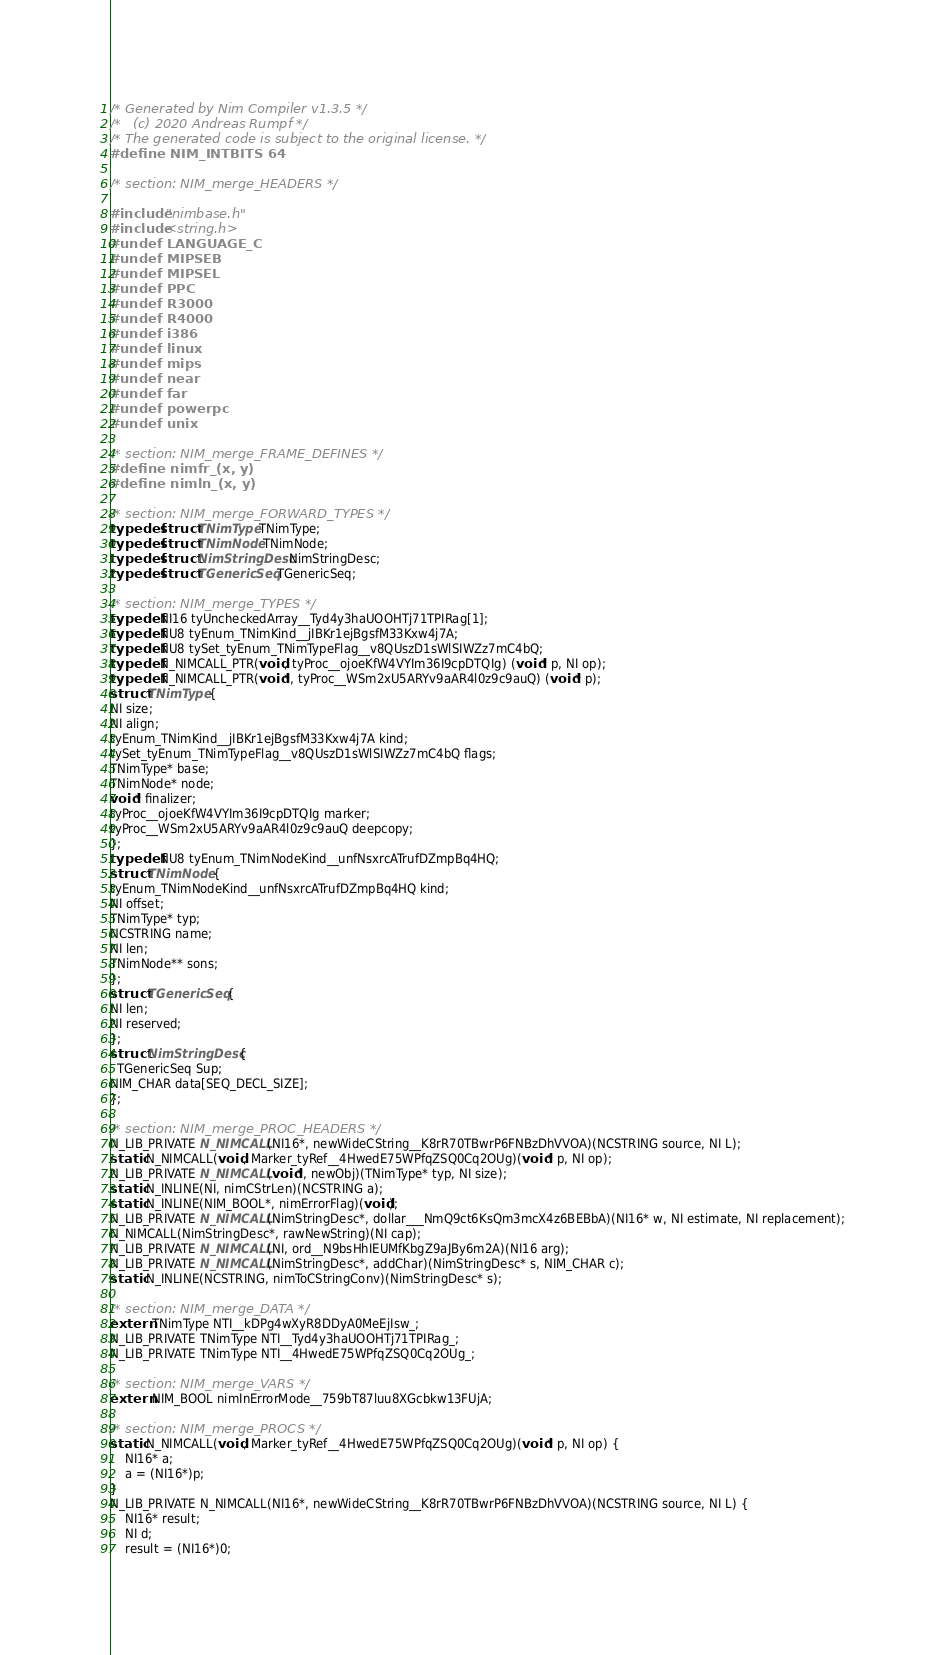<code> <loc_0><loc_0><loc_500><loc_500><_C_>/* Generated by Nim Compiler v1.3.5 */
/*   (c) 2020 Andreas Rumpf */
/* The generated code is subject to the original license. */
#define NIM_INTBITS 64

/* section: NIM_merge_HEADERS */

#include "nimbase.h"
#include <string.h>
#undef LANGUAGE_C
#undef MIPSEB
#undef MIPSEL
#undef PPC
#undef R3000
#undef R4000
#undef i386
#undef linux
#undef mips
#undef near
#undef far
#undef powerpc
#undef unix

/* section: NIM_merge_FRAME_DEFINES */
#define nimfr_(x, y)
#define nimln_(x, y)

/* section: NIM_merge_FORWARD_TYPES */
typedef struct TNimType TNimType;
typedef struct TNimNode TNimNode;
typedef struct NimStringDesc NimStringDesc;
typedef struct TGenericSeq TGenericSeq;

/* section: NIM_merge_TYPES */
typedef NI16 tyUncheckedArray__Tyd4y3haUOOHTj71TPIRag[1];
typedef NU8 tyEnum_TNimKind__jIBKr1ejBgsfM33Kxw4j7A;
typedef NU8 tySet_tyEnum_TNimTypeFlag__v8QUszD1sWlSIWZz7mC4bQ;
typedef N_NIMCALL_PTR(void, tyProc__ojoeKfW4VYIm36I9cpDTQIg) (void* p, NI op);
typedef N_NIMCALL_PTR(void*, tyProc__WSm2xU5ARYv9aAR4l0z9c9auQ) (void* p);
struct TNimType {
NI size;
NI align;
tyEnum_TNimKind__jIBKr1ejBgsfM33Kxw4j7A kind;
tySet_tyEnum_TNimTypeFlag__v8QUszD1sWlSIWZz7mC4bQ flags;
TNimType* base;
TNimNode* node;
void* finalizer;
tyProc__ojoeKfW4VYIm36I9cpDTQIg marker;
tyProc__WSm2xU5ARYv9aAR4l0z9c9auQ deepcopy;
};
typedef NU8 tyEnum_TNimNodeKind__unfNsxrcATrufDZmpBq4HQ;
struct TNimNode {
tyEnum_TNimNodeKind__unfNsxrcATrufDZmpBq4HQ kind;
NI offset;
TNimType* typ;
NCSTRING name;
NI len;
TNimNode** sons;
};
struct TGenericSeq {
NI len;
NI reserved;
};
struct NimStringDesc {
  TGenericSeq Sup;
NIM_CHAR data[SEQ_DECL_SIZE];
};

/* section: NIM_merge_PROC_HEADERS */
N_LIB_PRIVATE N_NIMCALL(NI16*, newWideCString__K8rR70TBwrP6FNBzDhVVOA)(NCSTRING source, NI L);
static N_NIMCALL(void, Marker_tyRef__4HwedE75WPfqZSQ0Cq2OUg)(void* p, NI op);
N_LIB_PRIVATE N_NIMCALL(void*, newObj)(TNimType* typ, NI size);
static N_INLINE(NI, nimCStrLen)(NCSTRING a);
static N_INLINE(NIM_BOOL*, nimErrorFlag)(void);
N_LIB_PRIVATE N_NIMCALL(NimStringDesc*, dollar___NmQ9ct6KsQm3mcX4z6BEBbA)(NI16* w, NI estimate, NI replacement);
N_NIMCALL(NimStringDesc*, rawNewString)(NI cap);
N_LIB_PRIVATE N_NIMCALL(NI, ord__N9bsHhIEUMfKbgZ9aJBy6m2A)(NI16 arg);
N_LIB_PRIVATE N_NIMCALL(NimStringDesc*, addChar)(NimStringDesc* s, NIM_CHAR c);
static N_INLINE(NCSTRING, nimToCStringConv)(NimStringDesc* s);

/* section: NIM_merge_DATA */
extern TNimType NTI__kDPg4wXyR8DDyA0MeEjIsw_;
N_LIB_PRIVATE TNimType NTI__Tyd4y3haUOOHTj71TPIRag_;
N_LIB_PRIVATE TNimType NTI__4HwedE75WPfqZSQ0Cq2OUg_;

/* section: NIM_merge_VARS */
extern NIM_BOOL nimInErrorMode__759bT87luu8XGcbkw13FUjA;

/* section: NIM_merge_PROCS */
static N_NIMCALL(void, Marker_tyRef__4HwedE75WPfqZSQ0Cq2OUg)(void* p, NI op) {
	NI16* a;
	a = (NI16*)p;
}
N_LIB_PRIVATE N_NIMCALL(NI16*, newWideCString__K8rR70TBwrP6FNBzDhVVOA)(NCSTRING source, NI L) {
	NI16* result;
	NI d;
	result = (NI16*)0;</code> 